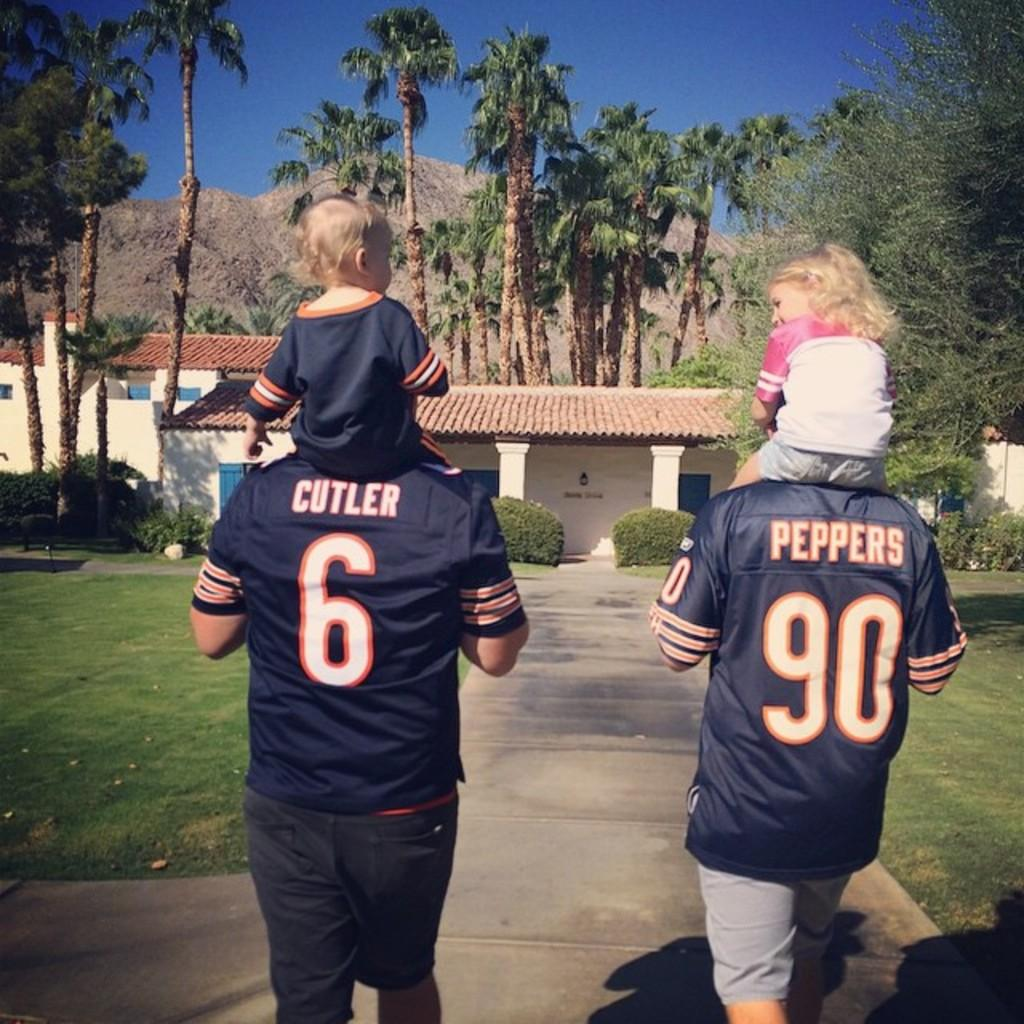Provide a one-sentence caption for the provided image. Men in Cutler and Peppers uniforms carry children on their back as they walk down a sidewalk. 